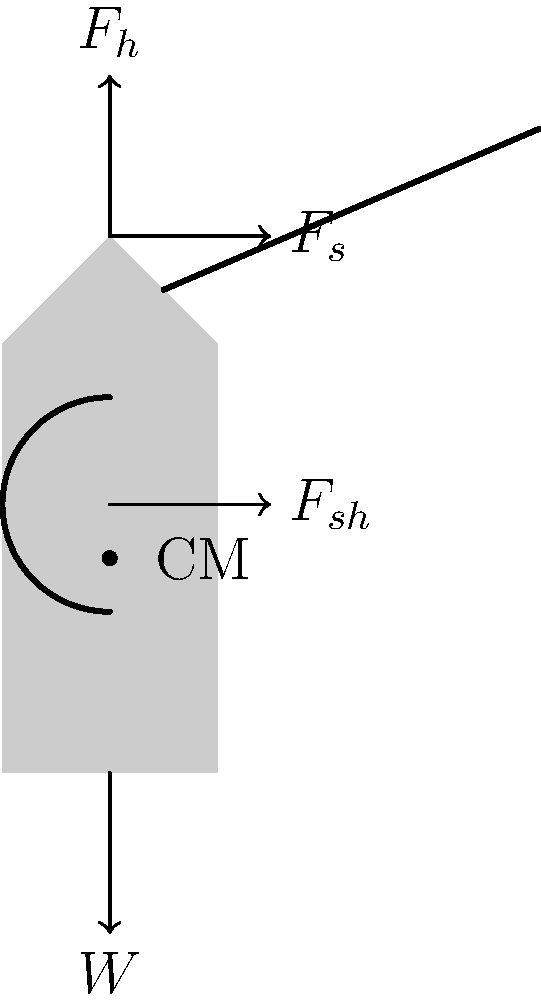An Aztec warrior is carrying a spear and shield in combat stance. The warrior's mass is 70 kg, the spear weighs 2 kg, and the shield weighs 5 kg. Given that the warrior's center of mass is located at 0.6 times their height from the ground, calculate the magnitude of the horizontal force ($F_s$) required to maintain equilibrium if the spear is held at a 30° angle above the horizontal. Assume g = 9.8 m/s². To solve this problem, we'll use a pragmatic approach based on biomechanics principles:

1) First, calculate the total weight:
   $W_{total} = (70 + 2 + 5) \text{ kg} \times 9.8 \text{ m/s²} = 754.6 \text{ N}$

2) The vertical component of the spear force:
   $F_v = 2 \text{ kg} \times 9.8 \text{ m/s²} \times \sin(30°) = 9.8 \text{ N}$

3) For vertical equilibrium:
   $F_h = W_{total} - F_v = 754.6 \text{ N} - 9.8 \text{ N} = 744.8 \text{ N}$

4) The horizontal component of the spear force:
   $F_{s_x} = 2 \text{ kg} \times 9.8 \text{ m/s²} \times \cos(30°) = 16.98 \text{ N}$

5) The shield force $F_{sh}$ is assumed to be purely horizontal.

6) For horizontal equilibrium:
   $F_s + F_{sh} - F_{s_x} = 0$

7) We need to find the moment around the center of mass to determine $F_{sh}$:
   $F_s \times 0.4h + F_{sh} \times 0.1h - F_{s_x} \times 0.6h = 0$
   where $h$ is the warrior's height.

8) Substituting $F_{sh} = F_{s_x} - F_s$ from step 6 into the equation from step 7:
   $F_s \times 0.4h + (F_{s_x} - F_s) \times 0.1h - F_{s_x} \times 0.6h = 0$

9) Simplifying:
   $0.4F_s - 0.1F_s = 0.5F_{s_x}$
   $0.3F_s = 0.5 \times 16.98 \text{ N}$
   $F_s = 28.3 \text{ N}$

Therefore, the horizontal force $F_s$ required to maintain equilibrium is approximately 28.3 N.
Answer: 28.3 N 